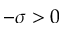Convert formula to latex. <formula><loc_0><loc_0><loc_500><loc_500>- \sigma > 0</formula> 